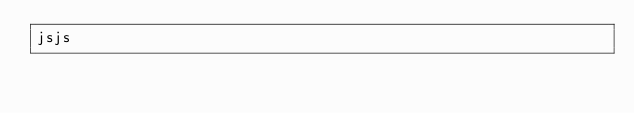<code> <loc_0><loc_0><loc_500><loc_500><_JavaScript_>jsjs
</code> 